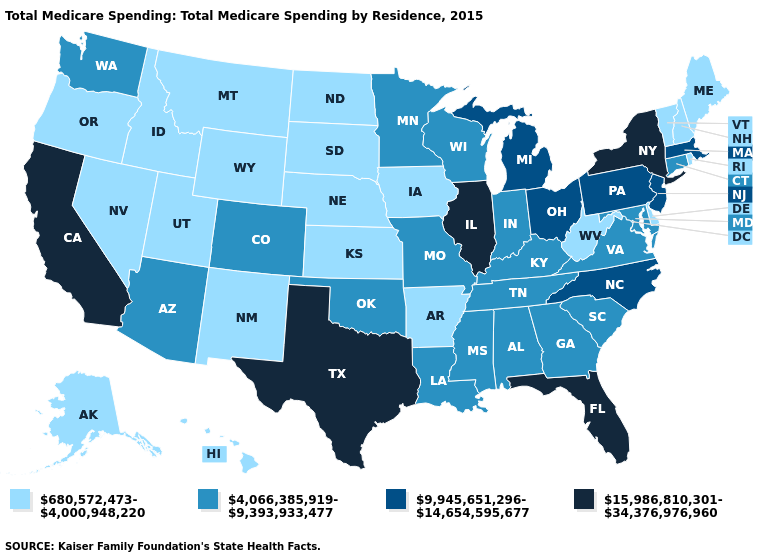Name the states that have a value in the range 4,066,385,919-9,393,933,477?
Answer briefly. Alabama, Arizona, Colorado, Connecticut, Georgia, Indiana, Kentucky, Louisiana, Maryland, Minnesota, Mississippi, Missouri, Oklahoma, South Carolina, Tennessee, Virginia, Washington, Wisconsin. What is the lowest value in the West?
Answer briefly. 680,572,473-4,000,948,220. Does Oklahoma have a higher value than Colorado?
Be succinct. No. What is the lowest value in the MidWest?
Answer briefly. 680,572,473-4,000,948,220. Among the states that border Kentucky , which have the highest value?
Be succinct. Illinois. Which states hav the highest value in the MidWest?
Answer briefly. Illinois. Does South Dakota have the same value as Pennsylvania?
Answer briefly. No. Name the states that have a value in the range 4,066,385,919-9,393,933,477?
Give a very brief answer. Alabama, Arizona, Colorado, Connecticut, Georgia, Indiana, Kentucky, Louisiana, Maryland, Minnesota, Mississippi, Missouri, Oklahoma, South Carolina, Tennessee, Virginia, Washington, Wisconsin. What is the value of Maryland?
Concise answer only. 4,066,385,919-9,393,933,477. How many symbols are there in the legend?
Quick response, please. 4. Name the states that have a value in the range 15,986,810,301-34,376,976,960?
Short answer required. California, Florida, Illinois, New York, Texas. Name the states that have a value in the range 4,066,385,919-9,393,933,477?
Answer briefly. Alabama, Arizona, Colorado, Connecticut, Georgia, Indiana, Kentucky, Louisiana, Maryland, Minnesota, Mississippi, Missouri, Oklahoma, South Carolina, Tennessee, Virginia, Washington, Wisconsin. What is the lowest value in the USA?
Keep it brief. 680,572,473-4,000,948,220. Among the states that border Mississippi , does Arkansas have the highest value?
Quick response, please. No. Does Nevada have the highest value in the USA?
Keep it brief. No. 